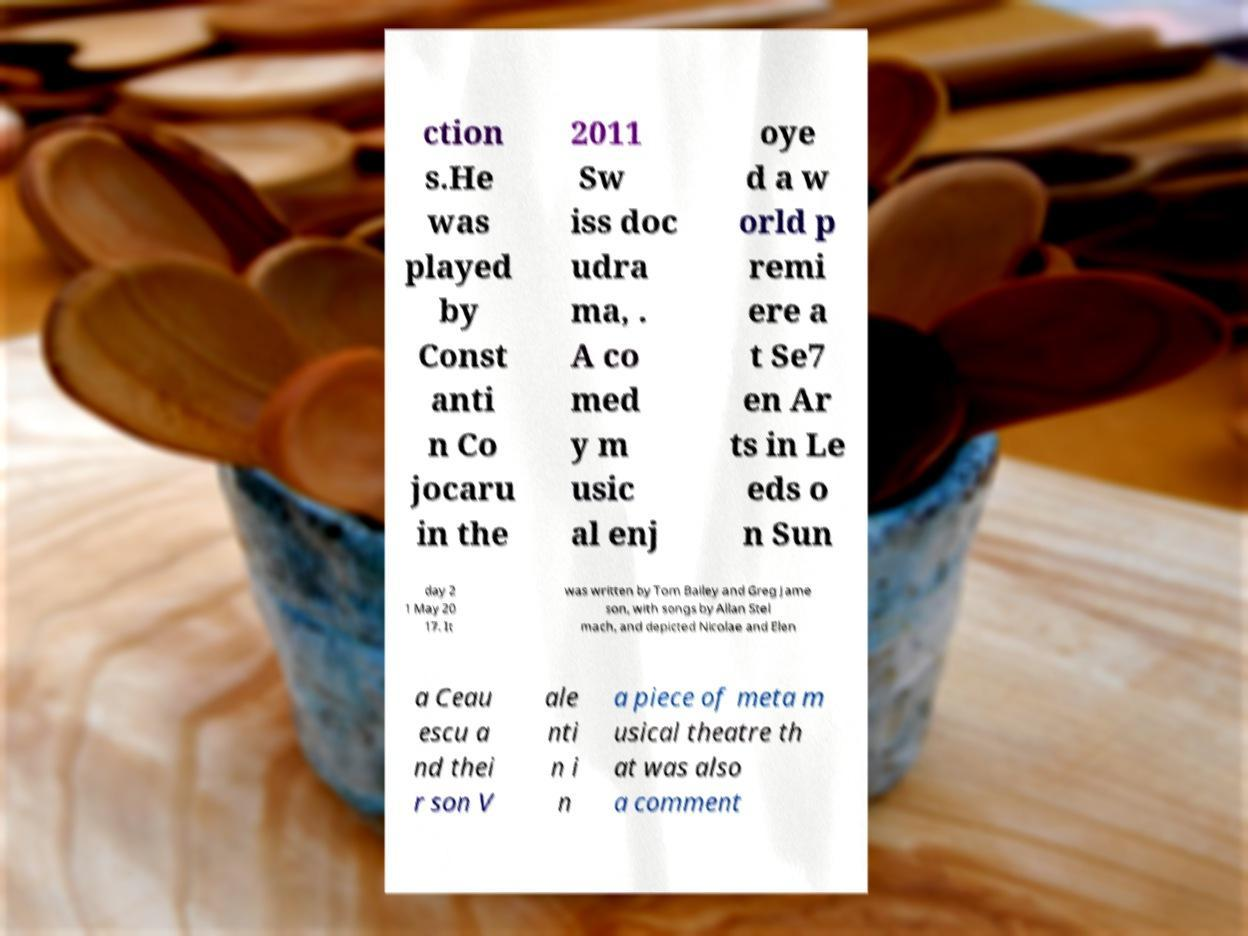I need the written content from this picture converted into text. Can you do that? ction s.He was played by Const anti n Co jocaru in the 2011 Sw iss doc udra ma, . A co med y m usic al enj oye d a w orld p remi ere a t Se7 en Ar ts in Le eds o n Sun day 2 1 May 20 17. It was written by Tom Bailey and Greg Jame son, with songs by Allan Stel mach, and depicted Nicolae and Elen a Ceau escu a nd thei r son V ale nti n i n a piece of meta m usical theatre th at was also a comment 